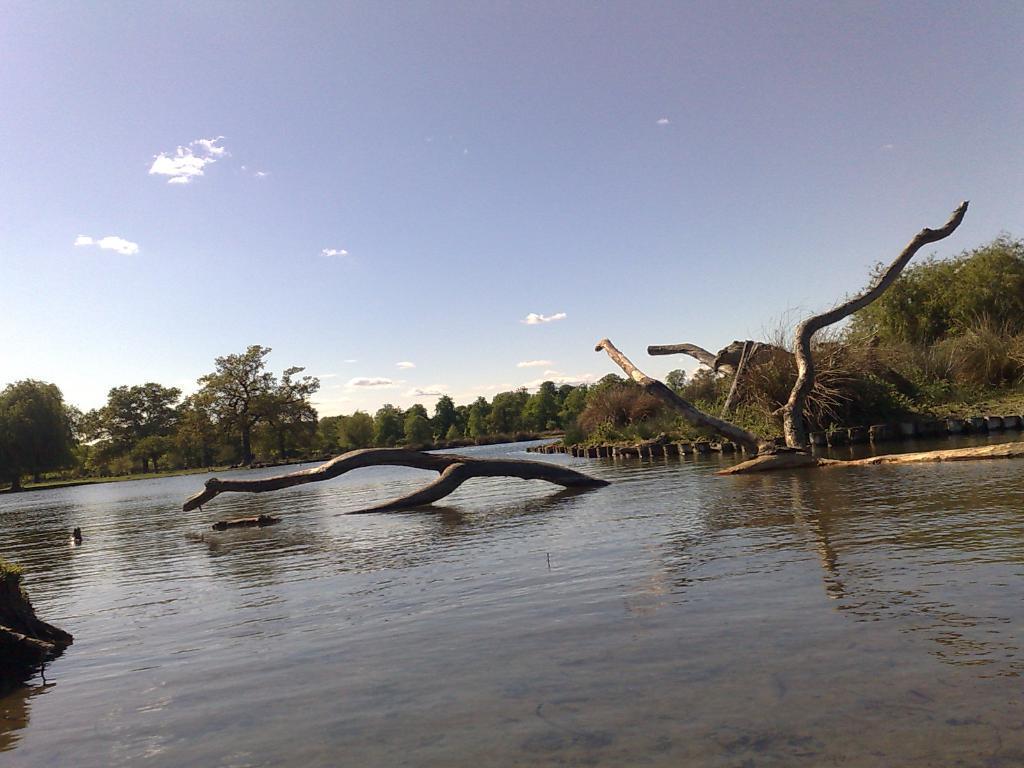Could you give a brief overview of what you see in this image? In this picture we can see a river surrounded with trees and plants. Here the sky is bright. 